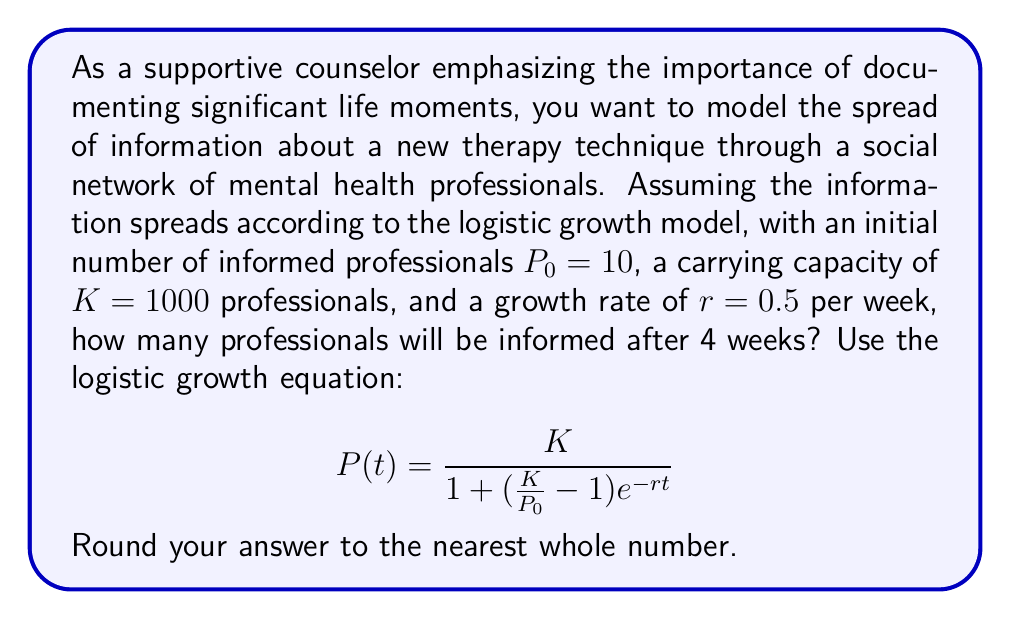Show me your answer to this math problem. To solve this problem, we'll follow these steps:

1. Identify the given parameters:
   $K = 1000$ (carrying capacity)
   $P_0 = 10$ (initial number of informed professionals)
   $r = 0.5$ (growth rate per week)
   $t = 4$ (time in weeks)

2. Substitute these values into the logistic growth equation:

   $$P(4) = \frac{1000}{1 + (\frac{1000}{10} - 1)e^{-0.5 \cdot 4}}$$

3. Simplify the expression inside the parentheses:
   $$\frac{1000}{10} - 1 = 100 - 1 = 99$$

4. Calculate the exponent:
   $$-0.5 \cdot 4 = -2$$

5. Simplify the equation:
   $$P(4) = \frac{1000}{1 + 99e^{-2}}$$

6. Calculate $e^{-2}$:
   $$e^{-2} \approx 0.1353$$

7. Multiply:
   $$99 \cdot 0.1353 \approx 13.3947$$

8. Add 1 to the denominator:
   $$1 + 13.3947 \approx 14.3947$$

9. Divide:
   $$\frac{1000}{14.3947} \approx 69.4699$$

10. Round to the nearest whole number:
    $$69.4699 \approx 69$$

Therefore, after 4 weeks, approximately 69 mental health professionals will be informed about the new therapy technique.
Answer: 69 professionals 